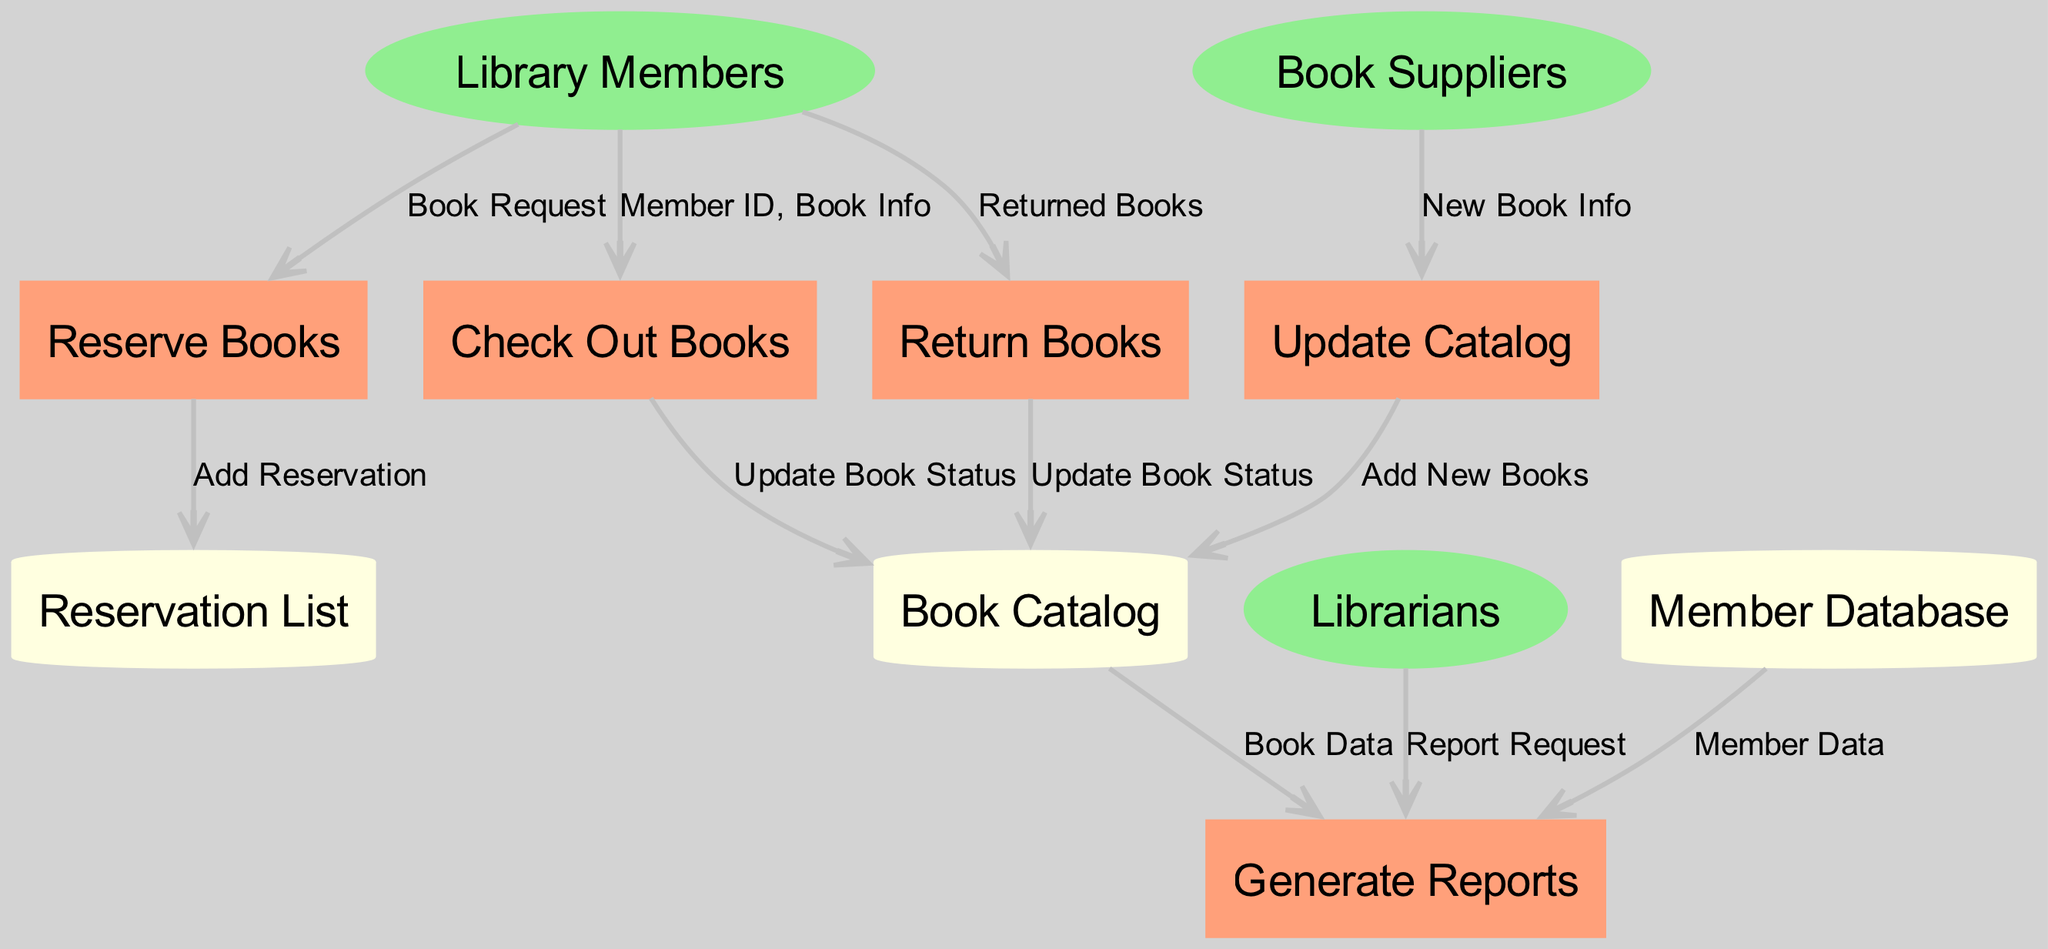What are the external entities in the diagram? The external entities are Library Members, Librarians, and Book Suppliers. These represent the key actors interacting with the system.
Answer: Library Members, Librarians, Book Suppliers How many processes are there in the system? The diagram contains five processes which are Check Out Books, Return Books, Reserve Books, Update Catalog, and Generate Reports. Counting them leads to this total.
Answer: 5 What data flow comes from Library Members to Check Out Books? The data flow from Library Members to Check Out Books carries the Member ID and Book Info, as explicitly stated in the diagram labels.
Answer: Member ID, Book Info Which process updates the Book Catalog when books are returned? The Return Books process updates the Book Catalog by sending an Update Book Status signal, connecting the returned books with the catalog updates.
Answer: Return Books What is added to the Reservation List by the Reserve Books process? The Reserve Books process adds a reservation represented by the label "Add Reservation." This signifies the direct action taken by the process on the data store.
Answer: Add Reservation Which external entity requests report generation? Only Librarians are shown as an external entity that sends a Report Request to the Generate Reports process, indicating their role in the reporting functionality.
Answer: Librarians How many data stores are present in the diagram? The diagram illustrates three data stores, namely Member Database, Book Catalog, and Reservation List, which store the required data for the processes.
Answer: 3 What type of data flows into the Generate Reports process? Data flows from Book Catalog and Member Database to the Generate Reports process, specifically Book Data and Member Data respectively. These are necessary for report generation.
Answer: Book Data, Member Data What process is responsible for adding new books to the Book Catalog? The Update Catalog process is responsible for adding new books, as it directly feeds information from Book Suppliers and acts on the Book Catalog.
Answer: Update Catalog 